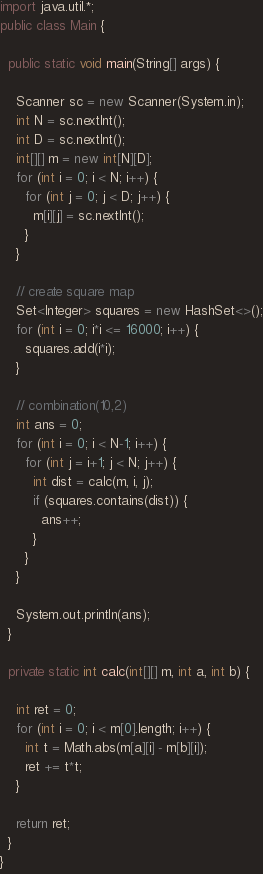<code> <loc_0><loc_0><loc_500><loc_500><_Java_>import java.util.*;
public class Main {
  
  public static void main(String[] args) {

    Scanner sc = new Scanner(System.in);
    int N = sc.nextInt();
    int D = sc.nextInt();
    int[][] m = new int[N][D];
    for (int i = 0; i < N; i++) {
      for (int j = 0; j < D; j++) {
        m[i][j] = sc.nextInt();
      }
    }
    
    // create square map
    Set<Integer> squares = new HashSet<>();
    for (int i = 0; i*i <= 16000; i++) {
      squares.add(i*i);
    }
    
    // combination(10,2)
    int ans = 0;
    for (int i = 0; i < N-1; i++) {
      for (int j = i+1; j < N; j++) {
        int dist = calc(m, i, j);
        if (squares.contains(dist)) {
          ans++;
        }
      }
    }

    System.out.println(ans);
  }
  
  private static int calc(int[][] m, int a, int b) {

    int ret = 0;
    for (int i = 0; i < m[0].length; i++) {
      int t = Math.abs(m[a][i] - m[b][i]);
      ret += t*t;
    }
    
    return ret;
  }
}
</code> 